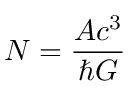<formula> <loc_0><loc_0><loc_500><loc_500>N = { \frac { A c ^ { 3 } } { \hbar { G } } }</formula> 